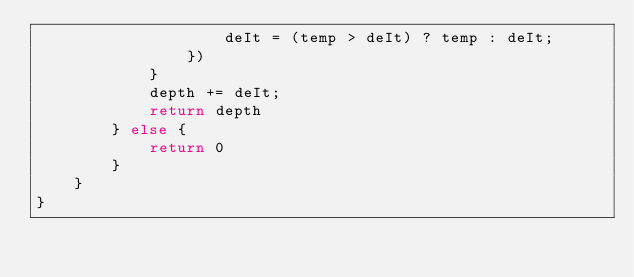Convert code to text. <code><loc_0><loc_0><loc_500><loc_500><_JavaScript_>                    deIt = (temp > deIt) ? temp : deIt;
                })
            }
            depth += deIt;
            return depth
        } else {
            return 0
        }
    }
}</code> 